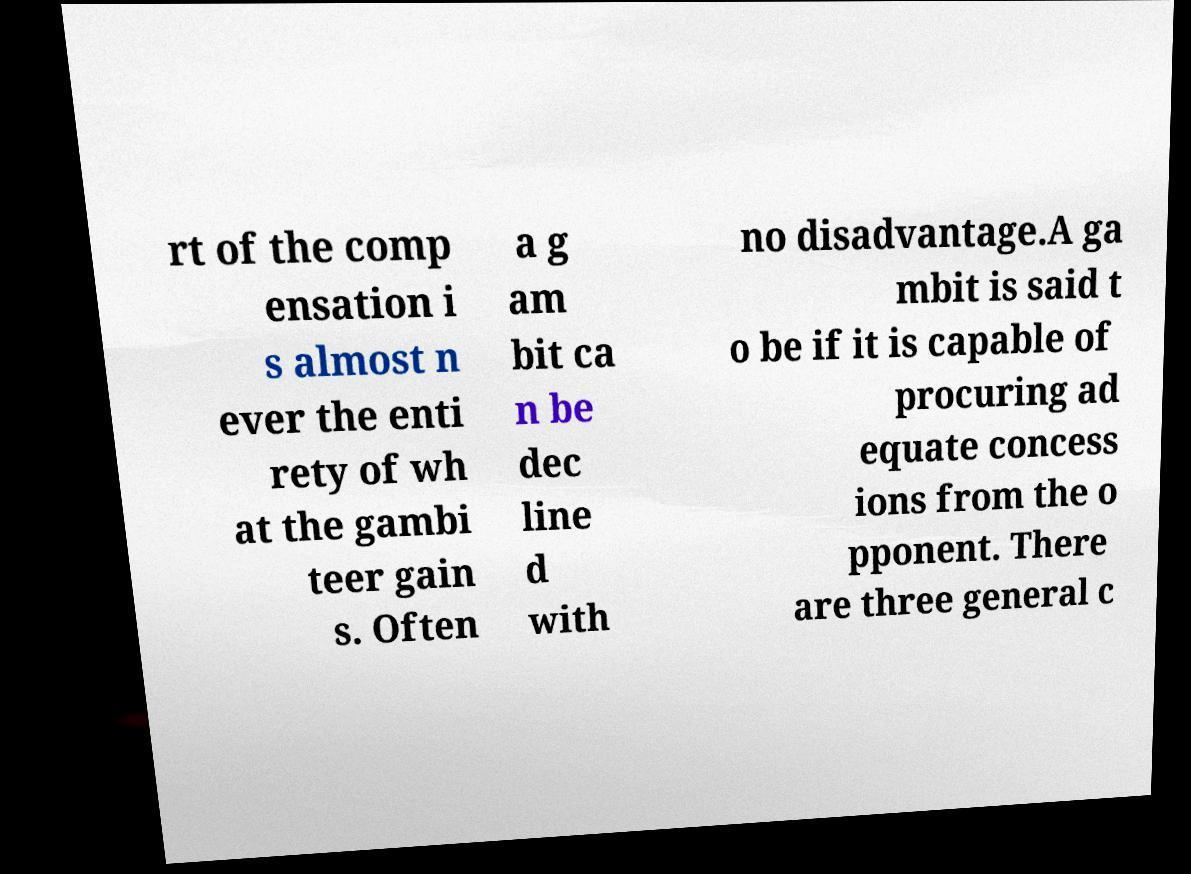There's text embedded in this image that I need extracted. Can you transcribe it verbatim? rt of the comp ensation i s almost n ever the enti rety of wh at the gambi teer gain s. Often a g am bit ca n be dec line d with no disadvantage.A ga mbit is said t o be if it is capable of procuring ad equate concess ions from the o pponent. There are three general c 